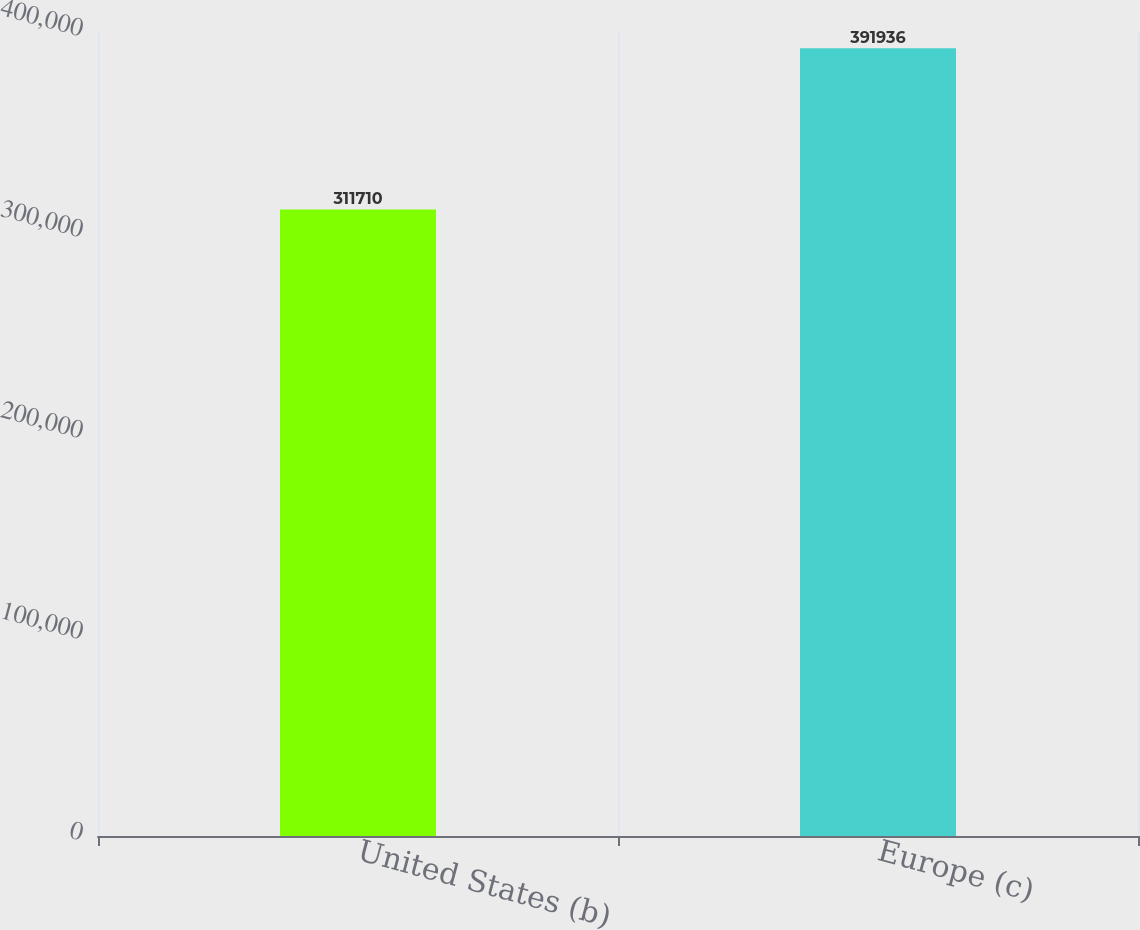<chart> <loc_0><loc_0><loc_500><loc_500><bar_chart><fcel>United States (b)<fcel>Europe (c)<nl><fcel>311710<fcel>391936<nl></chart> 